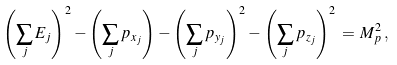Convert formula to latex. <formula><loc_0><loc_0><loc_500><loc_500>\left ( \sum _ { j } E _ { j } \right ) ^ { 2 } - \left ( \sum _ { j } p _ { x _ { j } } \right ) - \left ( \sum _ { j } p _ { y _ { j } } \right ) ^ { 2 } - \left ( \sum _ { j } p _ { z _ { j } } \right ) ^ { 2 } \, = \, M _ { p } ^ { 2 } \, ,</formula> 